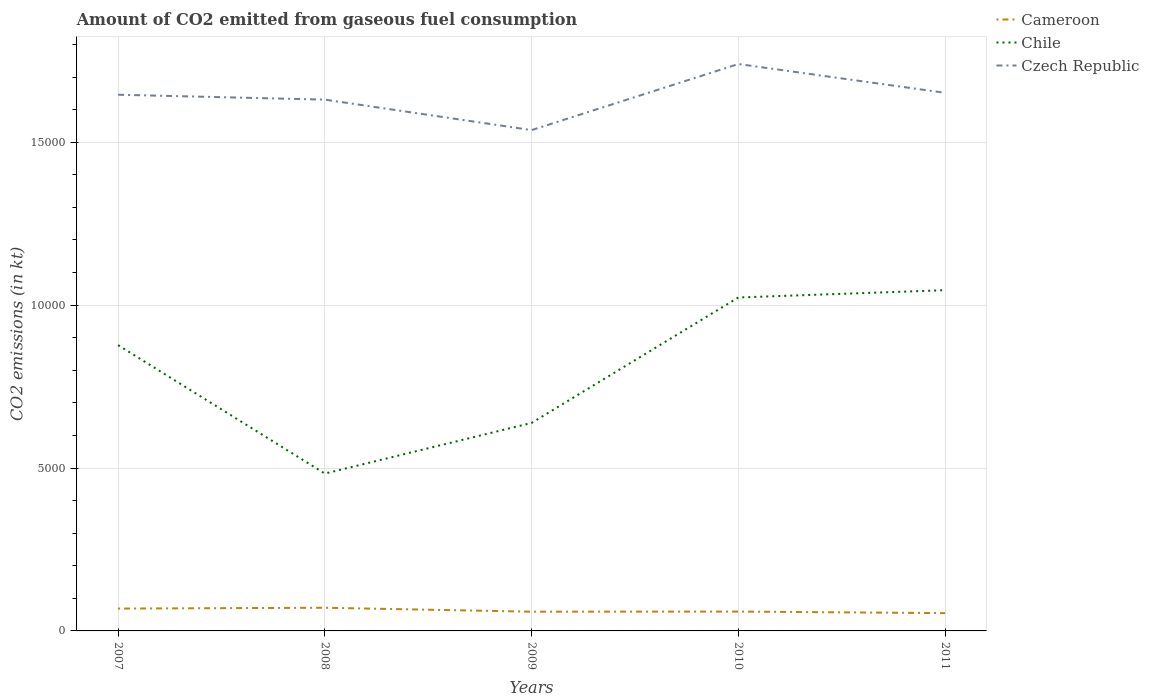How many different coloured lines are there?
Offer a terse response. 3. Across all years, what is the maximum amount of CO2 emitted in Czech Republic?
Your answer should be compact. 1.54e+04. In which year was the amount of CO2 emitted in Cameroon maximum?
Give a very brief answer. 2011. What is the total amount of CO2 emitted in Cameroon in the graph?
Make the answer very short. 121.01. What is the difference between the highest and the second highest amount of CO2 emitted in Czech Republic?
Ensure brevity in your answer.  2027.85. What is the difference between the highest and the lowest amount of CO2 emitted in Czech Republic?
Make the answer very short. 3. What is the difference between two consecutive major ticks on the Y-axis?
Give a very brief answer. 5000. Are the values on the major ticks of Y-axis written in scientific E-notation?
Provide a short and direct response. No. Where does the legend appear in the graph?
Offer a terse response. Top right. How many legend labels are there?
Make the answer very short. 3. What is the title of the graph?
Ensure brevity in your answer.  Amount of CO2 emitted from gaseous fuel consumption. What is the label or title of the X-axis?
Your response must be concise. Years. What is the label or title of the Y-axis?
Offer a terse response. CO2 emissions (in kt). What is the CO2 emissions (in kt) in Cameroon in 2007?
Give a very brief answer. 685.73. What is the CO2 emissions (in kt) in Chile in 2007?
Your answer should be very brief. 8771.46. What is the CO2 emissions (in kt) in Czech Republic in 2007?
Provide a succinct answer. 1.65e+04. What is the CO2 emissions (in kt) in Cameroon in 2008?
Your answer should be compact. 711.4. What is the CO2 emissions (in kt) of Chile in 2008?
Give a very brief answer. 4829.44. What is the CO2 emissions (in kt) in Czech Republic in 2008?
Offer a very short reply. 1.63e+04. What is the CO2 emissions (in kt) in Cameroon in 2009?
Your response must be concise. 590.39. What is the CO2 emissions (in kt) of Chile in 2009?
Your response must be concise. 6384.25. What is the CO2 emissions (in kt) in Czech Republic in 2009?
Offer a very short reply. 1.54e+04. What is the CO2 emissions (in kt) in Cameroon in 2010?
Provide a short and direct response. 594.05. What is the CO2 emissions (in kt) in Chile in 2010?
Your answer should be compact. 1.02e+04. What is the CO2 emissions (in kt) in Czech Republic in 2010?
Offer a very short reply. 1.74e+04. What is the CO2 emissions (in kt) of Cameroon in 2011?
Your answer should be very brief. 546.38. What is the CO2 emissions (in kt) in Chile in 2011?
Provide a succinct answer. 1.05e+04. What is the CO2 emissions (in kt) of Czech Republic in 2011?
Ensure brevity in your answer.  1.65e+04. Across all years, what is the maximum CO2 emissions (in kt) of Cameroon?
Offer a terse response. 711.4. Across all years, what is the maximum CO2 emissions (in kt) of Chile?
Provide a succinct answer. 1.05e+04. Across all years, what is the maximum CO2 emissions (in kt) of Czech Republic?
Offer a terse response. 1.74e+04. Across all years, what is the minimum CO2 emissions (in kt) of Cameroon?
Provide a short and direct response. 546.38. Across all years, what is the minimum CO2 emissions (in kt) in Chile?
Offer a very short reply. 4829.44. Across all years, what is the minimum CO2 emissions (in kt) in Czech Republic?
Keep it short and to the point. 1.54e+04. What is the total CO2 emissions (in kt) of Cameroon in the graph?
Keep it short and to the point. 3127.95. What is the total CO2 emissions (in kt) in Chile in the graph?
Give a very brief answer. 4.07e+04. What is the total CO2 emissions (in kt) of Czech Republic in the graph?
Provide a succinct answer. 8.21e+04. What is the difference between the CO2 emissions (in kt) of Cameroon in 2007 and that in 2008?
Provide a short and direct response. -25.67. What is the difference between the CO2 emissions (in kt) of Chile in 2007 and that in 2008?
Make the answer very short. 3942.03. What is the difference between the CO2 emissions (in kt) of Czech Republic in 2007 and that in 2008?
Provide a short and direct response. 150.35. What is the difference between the CO2 emissions (in kt) in Cameroon in 2007 and that in 2009?
Provide a succinct answer. 95.34. What is the difference between the CO2 emissions (in kt) in Chile in 2007 and that in 2009?
Keep it short and to the point. 2387.22. What is the difference between the CO2 emissions (in kt) of Czech Republic in 2007 and that in 2009?
Provide a short and direct response. 1085.43. What is the difference between the CO2 emissions (in kt) of Cameroon in 2007 and that in 2010?
Offer a very short reply. 91.67. What is the difference between the CO2 emissions (in kt) in Chile in 2007 and that in 2010?
Your answer should be very brief. -1463.13. What is the difference between the CO2 emissions (in kt) in Czech Republic in 2007 and that in 2010?
Offer a very short reply. -942.42. What is the difference between the CO2 emissions (in kt) in Cameroon in 2007 and that in 2011?
Offer a terse response. 139.35. What is the difference between the CO2 emissions (in kt) of Chile in 2007 and that in 2011?
Your response must be concise. -1686.82. What is the difference between the CO2 emissions (in kt) in Czech Republic in 2007 and that in 2011?
Offer a very short reply. -58.67. What is the difference between the CO2 emissions (in kt) in Cameroon in 2008 and that in 2009?
Keep it short and to the point. 121.01. What is the difference between the CO2 emissions (in kt) of Chile in 2008 and that in 2009?
Offer a very short reply. -1554.81. What is the difference between the CO2 emissions (in kt) of Czech Republic in 2008 and that in 2009?
Provide a succinct answer. 935.09. What is the difference between the CO2 emissions (in kt) of Cameroon in 2008 and that in 2010?
Your answer should be compact. 117.34. What is the difference between the CO2 emissions (in kt) in Chile in 2008 and that in 2010?
Offer a terse response. -5405.16. What is the difference between the CO2 emissions (in kt) of Czech Republic in 2008 and that in 2010?
Provide a short and direct response. -1092.77. What is the difference between the CO2 emissions (in kt) of Cameroon in 2008 and that in 2011?
Offer a very short reply. 165.01. What is the difference between the CO2 emissions (in kt) of Chile in 2008 and that in 2011?
Offer a terse response. -5628.85. What is the difference between the CO2 emissions (in kt) of Czech Republic in 2008 and that in 2011?
Give a very brief answer. -209.02. What is the difference between the CO2 emissions (in kt) of Cameroon in 2009 and that in 2010?
Provide a succinct answer. -3.67. What is the difference between the CO2 emissions (in kt) of Chile in 2009 and that in 2010?
Ensure brevity in your answer.  -3850.35. What is the difference between the CO2 emissions (in kt) of Czech Republic in 2009 and that in 2010?
Provide a succinct answer. -2027.85. What is the difference between the CO2 emissions (in kt) of Cameroon in 2009 and that in 2011?
Ensure brevity in your answer.  44. What is the difference between the CO2 emissions (in kt) of Chile in 2009 and that in 2011?
Make the answer very short. -4074.04. What is the difference between the CO2 emissions (in kt) in Czech Republic in 2009 and that in 2011?
Offer a terse response. -1144.1. What is the difference between the CO2 emissions (in kt) of Cameroon in 2010 and that in 2011?
Your answer should be compact. 47.67. What is the difference between the CO2 emissions (in kt) in Chile in 2010 and that in 2011?
Provide a succinct answer. -223.69. What is the difference between the CO2 emissions (in kt) of Czech Republic in 2010 and that in 2011?
Provide a succinct answer. 883.75. What is the difference between the CO2 emissions (in kt) in Cameroon in 2007 and the CO2 emissions (in kt) in Chile in 2008?
Provide a succinct answer. -4143.71. What is the difference between the CO2 emissions (in kt) in Cameroon in 2007 and the CO2 emissions (in kt) in Czech Republic in 2008?
Your answer should be compact. -1.56e+04. What is the difference between the CO2 emissions (in kt) in Chile in 2007 and the CO2 emissions (in kt) in Czech Republic in 2008?
Your answer should be compact. -7535.69. What is the difference between the CO2 emissions (in kt) in Cameroon in 2007 and the CO2 emissions (in kt) in Chile in 2009?
Ensure brevity in your answer.  -5698.52. What is the difference between the CO2 emissions (in kt) in Cameroon in 2007 and the CO2 emissions (in kt) in Czech Republic in 2009?
Your answer should be compact. -1.47e+04. What is the difference between the CO2 emissions (in kt) of Chile in 2007 and the CO2 emissions (in kt) of Czech Republic in 2009?
Make the answer very short. -6600.6. What is the difference between the CO2 emissions (in kt) of Cameroon in 2007 and the CO2 emissions (in kt) of Chile in 2010?
Keep it short and to the point. -9548.87. What is the difference between the CO2 emissions (in kt) in Cameroon in 2007 and the CO2 emissions (in kt) in Czech Republic in 2010?
Keep it short and to the point. -1.67e+04. What is the difference between the CO2 emissions (in kt) in Chile in 2007 and the CO2 emissions (in kt) in Czech Republic in 2010?
Offer a terse response. -8628.45. What is the difference between the CO2 emissions (in kt) in Cameroon in 2007 and the CO2 emissions (in kt) in Chile in 2011?
Your answer should be very brief. -9772.56. What is the difference between the CO2 emissions (in kt) of Cameroon in 2007 and the CO2 emissions (in kt) of Czech Republic in 2011?
Keep it short and to the point. -1.58e+04. What is the difference between the CO2 emissions (in kt) in Chile in 2007 and the CO2 emissions (in kt) in Czech Republic in 2011?
Provide a short and direct response. -7744.7. What is the difference between the CO2 emissions (in kt) of Cameroon in 2008 and the CO2 emissions (in kt) of Chile in 2009?
Ensure brevity in your answer.  -5672.85. What is the difference between the CO2 emissions (in kt) in Cameroon in 2008 and the CO2 emissions (in kt) in Czech Republic in 2009?
Provide a short and direct response. -1.47e+04. What is the difference between the CO2 emissions (in kt) in Chile in 2008 and the CO2 emissions (in kt) in Czech Republic in 2009?
Offer a terse response. -1.05e+04. What is the difference between the CO2 emissions (in kt) of Cameroon in 2008 and the CO2 emissions (in kt) of Chile in 2010?
Ensure brevity in your answer.  -9523.2. What is the difference between the CO2 emissions (in kt) in Cameroon in 2008 and the CO2 emissions (in kt) in Czech Republic in 2010?
Your answer should be very brief. -1.67e+04. What is the difference between the CO2 emissions (in kt) in Chile in 2008 and the CO2 emissions (in kt) in Czech Republic in 2010?
Ensure brevity in your answer.  -1.26e+04. What is the difference between the CO2 emissions (in kt) of Cameroon in 2008 and the CO2 emissions (in kt) of Chile in 2011?
Provide a short and direct response. -9746.89. What is the difference between the CO2 emissions (in kt) of Cameroon in 2008 and the CO2 emissions (in kt) of Czech Republic in 2011?
Ensure brevity in your answer.  -1.58e+04. What is the difference between the CO2 emissions (in kt) in Chile in 2008 and the CO2 emissions (in kt) in Czech Republic in 2011?
Offer a terse response. -1.17e+04. What is the difference between the CO2 emissions (in kt) in Cameroon in 2009 and the CO2 emissions (in kt) in Chile in 2010?
Provide a short and direct response. -9644.21. What is the difference between the CO2 emissions (in kt) in Cameroon in 2009 and the CO2 emissions (in kt) in Czech Republic in 2010?
Provide a short and direct response. -1.68e+04. What is the difference between the CO2 emissions (in kt) of Chile in 2009 and the CO2 emissions (in kt) of Czech Republic in 2010?
Make the answer very short. -1.10e+04. What is the difference between the CO2 emissions (in kt) in Cameroon in 2009 and the CO2 emissions (in kt) in Chile in 2011?
Keep it short and to the point. -9867.9. What is the difference between the CO2 emissions (in kt) in Cameroon in 2009 and the CO2 emissions (in kt) in Czech Republic in 2011?
Ensure brevity in your answer.  -1.59e+04. What is the difference between the CO2 emissions (in kt) of Chile in 2009 and the CO2 emissions (in kt) of Czech Republic in 2011?
Your response must be concise. -1.01e+04. What is the difference between the CO2 emissions (in kt) in Cameroon in 2010 and the CO2 emissions (in kt) in Chile in 2011?
Give a very brief answer. -9864.23. What is the difference between the CO2 emissions (in kt) in Cameroon in 2010 and the CO2 emissions (in kt) in Czech Republic in 2011?
Ensure brevity in your answer.  -1.59e+04. What is the difference between the CO2 emissions (in kt) of Chile in 2010 and the CO2 emissions (in kt) of Czech Republic in 2011?
Your answer should be compact. -6281.57. What is the average CO2 emissions (in kt) in Cameroon per year?
Provide a succinct answer. 625.59. What is the average CO2 emissions (in kt) of Chile per year?
Provide a short and direct response. 8135.61. What is the average CO2 emissions (in kt) of Czech Republic per year?
Your answer should be compact. 1.64e+04. In the year 2007, what is the difference between the CO2 emissions (in kt) of Cameroon and CO2 emissions (in kt) of Chile?
Provide a short and direct response. -8085.73. In the year 2007, what is the difference between the CO2 emissions (in kt) in Cameroon and CO2 emissions (in kt) in Czech Republic?
Keep it short and to the point. -1.58e+04. In the year 2007, what is the difference between the CO2 emissions (in kt) of Chile and CO2 emissions (in kt) of Czech Republic?
Ensure brevity in your answer.  -7686.03. In the year 2008, what is the difference between the CO2 emissions (in kt) in Cameroon and CO2 emissions (in kt) in Chile?
Offer a terse response. -4118.04. In the year 2008, what is the difference between the CO2 emissions (in kt) of Cameroon and CO2 emissions (in kt) of Czech Republic?
Provide a short and direct response. -1.56e+04. In the year 2008, what is the difference between the CO2 emissions (in kt) of Chile and CO2 emissions (in kt) of Czech Republic?
Your answer should be compact. -1.15e+04. In the year 2009, what is the difference between the CO2 emissions (in kt) of Cameroon and CO2 emissions (in kt) of Chile?
Provide a succinct answer. -5793.86. In the year 2009, what is the difference between the CO2 emissions (in kt) in Cameroon and CO2 emissions (in kt) in Czech Republic?
Provide a short and direct response. -1.48e+04. In the year 2009, what is the difference between the CO2 emissions (in kt) in Chile and CO2 emissions (in kt) in Czech Republic?
Offer a very short reply. -8987.82. In the year 2010, what is the difference between the CO2 emissions (in kt) of Cameroon and CO2 emissions (in kt) of Chile?
Offer a very short reply. -9640.54. In the year 2010, what is the difference between the CO2 emissions (in kt) of Cameroon and CO2 emissions (in kt) of Czech Republic?
Your response must be concise. -1.68e+04. In the year 2010, what is the difference between the CO2 emissions (in kt) in Chile and CO2 emissions (in kt) in Czech Republic?
Provide a succinct answer. -7165.32. In the year 2011, what is the difference between the CO2 emissions (in kt) of Cameroon and CO2 emissions (in kt) of Chile?
Keep it short and to the point. -9911.9. In the year 2011, what is the difference between the CO2 emissions (in kt) in Cameroon and CO2 emissions (in kt) in Czech Republic?
Give a very brief answer. -1.60e+04. In the year 2011, what is the difference between the CO2 emissions (in kt) of Chile and CO2 emissions (in kt) of Czech Republic?
Provide a succinct answer. -6057.88. What is the ratio of the CO2 emissions (in kt) in Cameroon in 2007 to that in 2008?
Provide a succinct answer. 0.96. What is the ratio of the CO2 emissions (in kt) of Chile in 2007 to that in 2008?
Provide a short and direct response. 1.82. What is the ratio of the CO2 emissions (in kt) of Czech Republic in 2007 to that in 2008?
Ensure brevity in your answer.  1.01. What is the ratio of the CO2 emissions (in kt) of Cameroon in 2007 to that in 2009?
Give a very brief answer. 1.16. What is the ratio of the CO2 emissions (in kt) in Chile in 2007 to that in 2009?
Provide a short and direct response. 1.37. What is the ratio of the CO2 emissions (in kt) in Czech Republic in 2007 to that in 2009?
Provide a short and direct response. 1.07. What is the ratio of the CO2 emissions (in kt) in Cameroon in 2007 to that in 2010?
Your answer should be compact. 1.15. What is the ratio of the CO2 emissions (in kt) in Chile in 2007 to that in 2010?
Keep it short and to the point. 0.86. What is the ratio of the CO2 emissions (in kt) of Czech Republic in 2007 to that in 2010?
Provide a short and direct response. 0.95. What is the ratio of the CO2 emissions (in kt) of Cameroon in 2007 to that in 2011?
Keep it short and to the point. 1.25. What is the ratio of the CO2 emissions (in kt) of Chile in 2007 to that in 2011?
Offer a very short reply. 0.84. What is the ratio of the CO2 emissions (in kt) of Cameroon in 2008 to that in 2009?
Keep it short and to the point. 1.21. What is the ratio of the CO2 emissions (in kt) of Chile in 2008 to that in 2009?
Provide a short and direct response. 0.76. What is the ratio of the CO2 emissions (in kt) of Czech Republic in 2008 to that in 2009?
Offer a very short reply. 1.06. What is the ratio of the CO2 emissions (in kt) in Cameroon in 2008 to that in 2010?
Your response must be concise. 1.2. What is the ratio of the CO2 emissions (in kt) of Chile in 2008 to that in 2010?
Make the answer very short. 0.47. What is the ratio of the CO2 emissions (in kt) of Czech Republic in 2008 to that in 2010?
Offer a terse response. 0.94. What is the ratio of the CO2 emissions (in kt) in Cameroon in 2008 to that in 2011?
Your answer should be very brief. 1.3. What is the ratio of the CO2 emissions (in kt) of Chile in 2008 to that in 2011?
Offer a terse response. 0.46. What is the ratio of the CO2 emissions (in kt) of Czech Republic in 2008 to that in 2011?
Provide a succinct answer. 0.99. What is the ratio of the CO2 emissions (in kt) of Cameroon in 2009 to that in 2010?
Provide a succinct answer. 0.99. What is the ratio of the CO2 emissions (in kt) of Chile in 2009 to that in 2010?
Give a very brief answer. 0.62. What is the ratio of the CO2 emissions (in kt) of Czech Republic in 2009 to that in 2010?
Offer a terse response. 0.88. What is the ratio of the CO2 emissions (in kt) of Cameroon in 2009 to that in 2011?
Your answer should be compact. 1.08. What is the ratio of the CO2 emissions (in kt) in Chile in 2009 to that in 2011?
Offer a very short reply. 0.61. What is the ratio of the CO2 emissions (in kt) in Czech Republic in 2009 to that in 2011?
Your response must be concise. 0.93. What is the ratio of the CO2 emissions (in kt) of Cameroon in 2010 to that in 2011?
Keep it short and to the point. 1.09. What is the ratio of the CO2 emissions (in kt) in Chile in 2010 to that in 2011?
Your answer should be compact. 0.98. What is the ratio of the CO2 emissions (in kt) in Czech Republic in 2010 to that in 2011?
Give a very brief answer. 1.05. What is the difference between the highest and the second highest CO2 emissions (in kt) in Cameroon?
Make the answer very short. 25.67. What is the difference between the highest and the second highest CO2 emissions (in kt) in Chile?
Your answer should be compact. 223.69. What is the difference between the highest and the second highest CO2 emissions (in kt) in Czech Republic?
Give a very brief answer. 883.75. What is the difference between the highest and the lowest CO2 emissions (in kt) in Cameroon?
Provide a succinct answer. 165.01. What is the difference between the highest and the lowest CO2 emissions (in kt) in Chile?
Keep it short and to the point. 5628.85. What is the difference between the highest and the lowest CO2 emissions (in kt) of Czech Republic?
Give a very brief answer. 2027.85. 